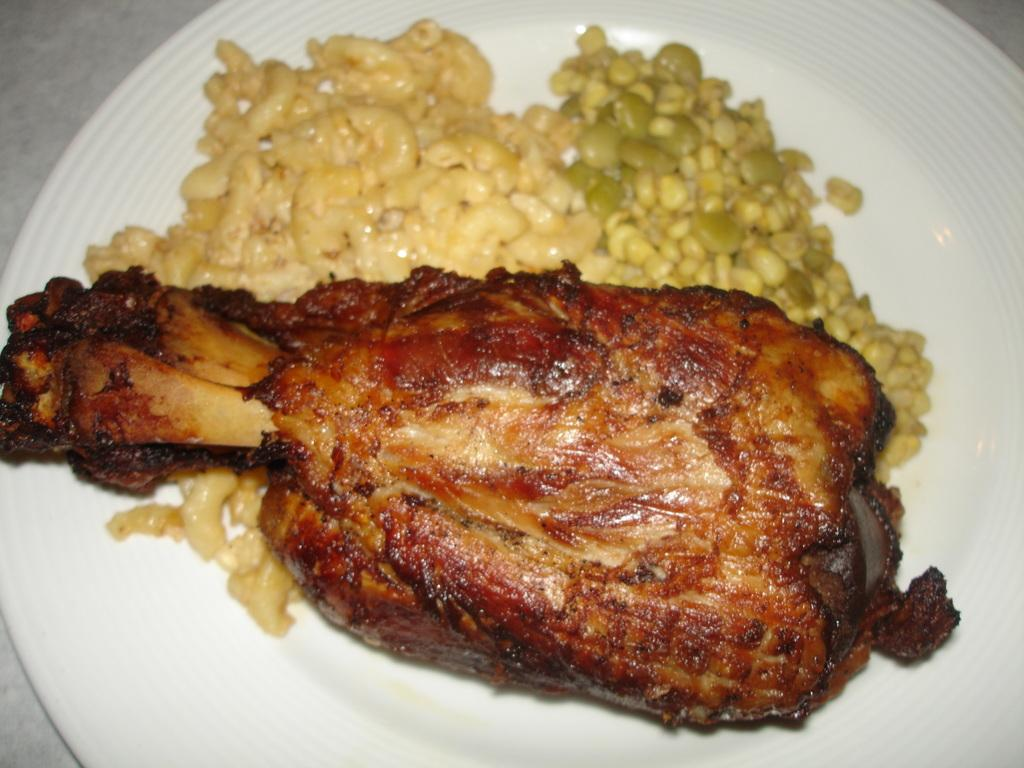What is on the plate that is visible in the image? There is pasta, peas, and meat on the plate. What type of food is the main component of the dish on the plate? The main component of the dish on the plate is pasta. Are there any other vegetables besides peas on the plate? No, the only vegetable visible on the plate is peas. What type of thrill can be experienced by the plate in the image? There is no indication of any thrill or excitement experienced by the plate in the image. 